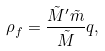<formula> <loc_0><loc_0><loc_500><loc_500>\rho _ { f } = \frac { { \tilde { M } ^ { \prime } } { \tilde { m } } } { \tilde { M } } q ,</formula> 